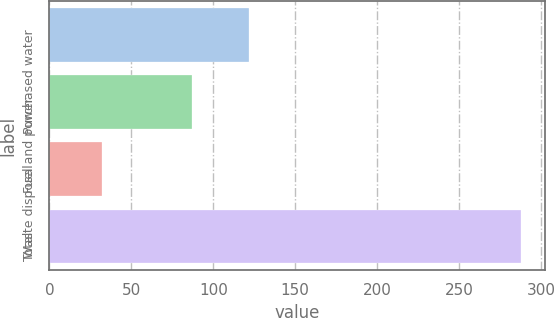Convert chart to OTSL. <chart><loc_0><loc_0><loc_500><loc_500><bar_chart><fcel>Purchased water<fcel>Fuel and power<fcel>Waste disposal<fcel>Total<nl><fcel>122<fcel>87<fcel>32<fcel>288<nl></chart> 